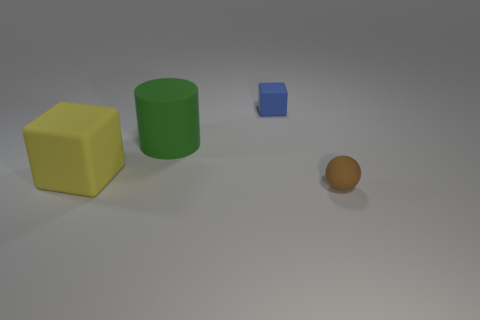What shape is the tiny matte object in front of the matte cube on the right side of the green object?
Make the answer very short. Sphere. What number of small things are blocks or purple matte cubes?
Make the answer very short. 1. How many brown objects have the same shape as the big green object?
Your answer should be very brief. 0. There is a blue object; is it the same shape as the small thing that is on the right side of the blue block?
Keep it short and to the point. No. How many tiny brown objects are in front of the blue matte cube?
Keep it short and to the point. 1. Are there any green rubber things that have the same size as the yellow thing?
Make the answer very short. Yes. There is a matte thing that is in front of the yellow cube; is it the same shape as the yellow rubber thing?
Make the answer very short. No. What color is the tiny rubber sphere?
Your answer should be very brief. Brown. Is there a big purple rubber object?
Provide a succinct answer. No. There is a ball that is made of the same material as the small block; what size is it?
Ensure brevity in your answer.  Small. 